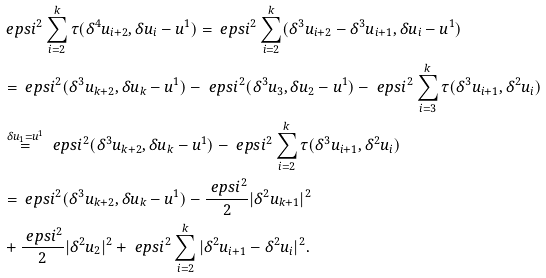<formula> <loc_0><loc_0><loc_500><loc_500>& \ e p s i ^ { 2 } \sum _ { i = 2 } ^ { k } \tau ( \delta ^ { 4 } u _ { i + 2 } , \delta u _ { i } - u ^ { 1 } ) = \ e p s i ^ { 2 } \sum _ { i = 2 } ^ { k } ( \delta ^ { 3 } u _ { i + 2 } - \delta ^ { 3 } u _ { i + 1 } , \delta u _ { i } - u ^ { 1 } ) \\ & = \ e p s i ^ { 2 } ( \delta ^ { 3 } u _ { k + 2 } , \delta u _ { k } - u ^ { 1 } ) - \ e p s i ^ { 2 } ( \delta ^ { 3 } u _ { 3 } , \delta u _ { 2 } - u ^ { 1 } ) - \ e p s i ^ { 2 } \sum _ { i = 3 } ^ { k } \tau ( \delta ^ { 3 } u _ { i + 1 } , \delta ^ { 2 } u _ { i } ) \\ & \stackrel { \delta u _ { 1 } = u ^ { 1 } } { = } \ e p s i ^ { 2 } ( \delta ^ { 3 } u _ { k + 2 } , \delta u _ { k } - u ^ { 1 } ) - \ e p s i ^ { 2 } \sum _ { i = 2 } ^ { k } \tau ( \delta ^ { 3 } u _ { i + 1 } , \delta ^ { 2 } u _ { i } ) \\ & = \ e p s i ^ { 2 } ( \delta ^ { 3 } u _ { k + 2 } , \delta u _ { k } - u ^ { 1 } ) - \frac { \ e p s i ^ { 2 } } { 2 } | \delta ^ { 2 } u _ { k + 1 } | ^ { 2 } \\ & + \frac { \ e p s i ^ { 2 } } { 2 } | \delta ^ { 2 } u _ { 2 } | ^ { 2 } + \ e p s i ^ { 2 } \sum _ { i = 2 } ^ { k } | \delta ^ { 2 } u _ { i + 1 } - \delta ^ { 2 } u _ { i } | ^ { 2 } .</formula> 